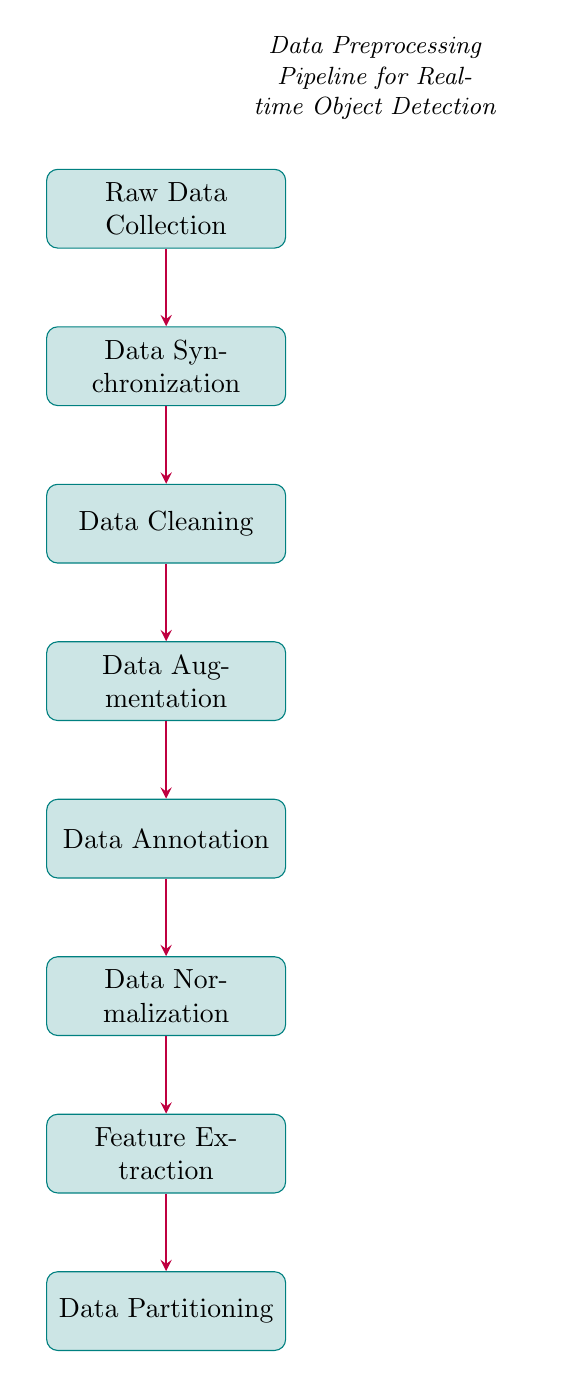What is the first step in the data preprocessing pipeline? The first node in the diagram is labeled "Raw Data Collection," which indicates the initial step in the process.
Answer: Raw Data Collection How many total steps are in the data preprocessing pipeline? By counting the nodes in the diagram, there are a total of eight steps, each representing a stage in the pipeline.
Answer: Eight Which step comes immediately after Data Augmentation? The diagram shows that after the "Data Augmentation" step, the next step is "Data Annotation."
Answer: Data Annotation What is the relationship between Data Normalization and Feature Extraction? The diagram indicates a direct arrow from "Data Normalization" to "Feature Extraction," showing that Normalization must be completed before Feature Extraction can proceed.
Answer: Direct relationship In which node is data noise removed? The "Data Cleaning" node specifically mentions the removal of noise and irrelevant data from the datasets, making it the correct answer.
Answer: Data Cleaning What is the purpose of Data Annotation in the pipeline? The "Data Annotation" node describes the step of labeling objects in the datasets, either manually or using automated tools, indicating its role in adding meaning to the data.
Answer: Label objects Which step involves applying transformations such as scaling and rotation? "Data Augmentation" is explicitly described as the step where transformations are applied to increase dataset diversity.
Answer: Data Augmentation What precedes Data Partitioning in the pipeline? According to the diagram, "Feature Extraction" is the final step before "Data Partitioning," which is responsible for splitting data into sets.
Answer: Feature Extraction What is the last step in the data preprocessing pipeline? The last node in the diagram is labeled "Data Partitioning," indicating the final stage in the preprocessing process.
Answer: Data Partitioning 